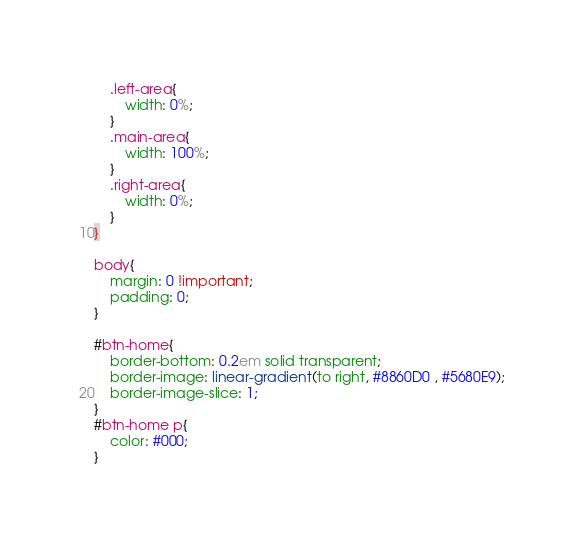<code> <loc_0><loc_0><loc_500><loc_500><_CSS_>    .left-area{
        width: 0%;
    }
    .main-area{
        width: 100%;
    }
    .right-area{
        width: 0%;
    }
}

body{
    margin: 0 !important;
    padding: 0;
}

#btn-home{
    border-bottom: 0.2em solid transparent;
    border-image: linear-gradient(to right, #8860D0 , #5680E9); 
    border-image-slice: 1; 
}
#btn-home p{
    color: #000;
}</code> 